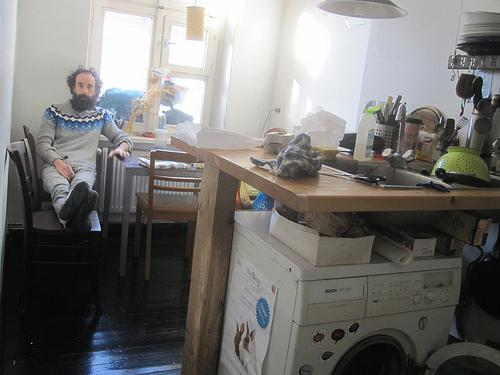Question: when was the picture taken?
Choices:
A. Night.
B. Winter.
C. Morning.
D. During the day.
Answer with the letter. Answer: D Question: who is in the picture?
Choices:
A. A man.
B. Mother.
C. Kids.
D. Man.
Answer with the letter. Answer: A Question: where was the picture taken?
Choices:
A. A kitchen.
B. Porch.
C. Kitchen.
D. France.
Answer with the letter. Answer: A Question: what color are the walls?
Choices:
A. Brown.
B. Gray.
C. White.
D. Blue.
Answer with the letter. Answer: C 